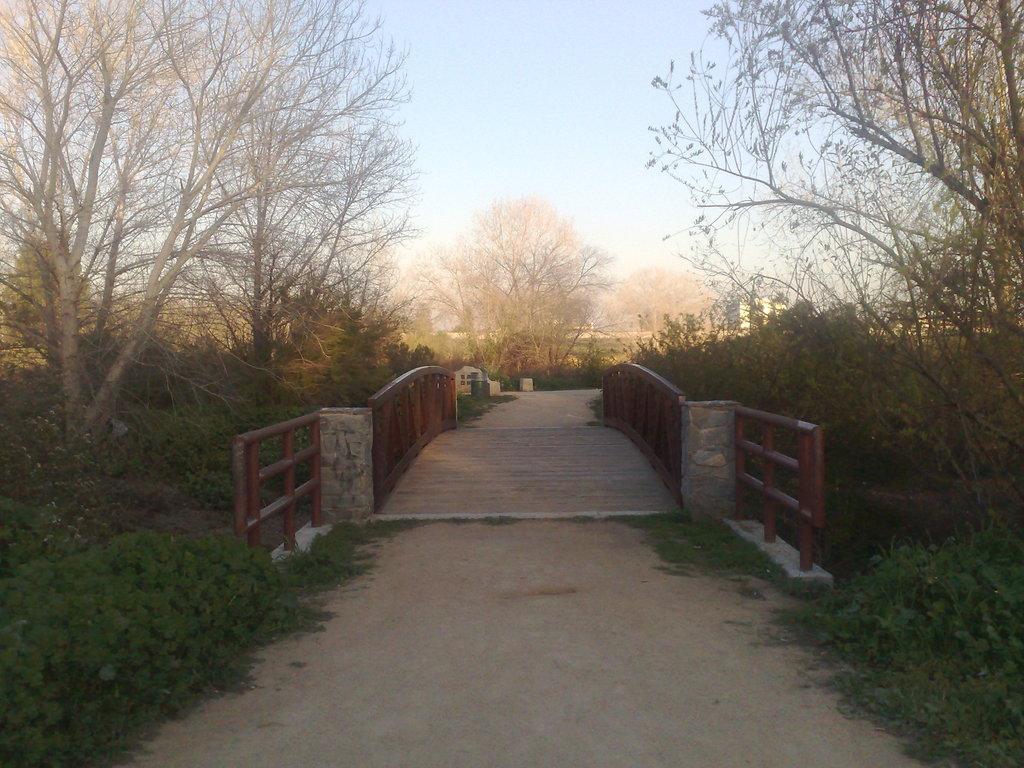In one or two sentences, can you explain what this image depicts? In this picture we see a narrow single lane bridge surrounded by trees and plants. 